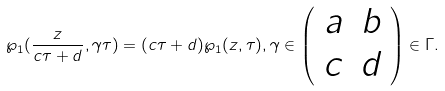Convert formula to latex. <formula><loc_0><loc_0><loc_500><loc_500>\wp _ { 1 } ( \frac { z } { c \tau + d } , \gamma \tau ) = ( c \tau + d ) \wp _ { 1 } ( z , \tau ) , \gamma \in \left ( \begin{array} { c c } a & b \\ c & d \end{array} \right ) \in \Gamma .</formula> 